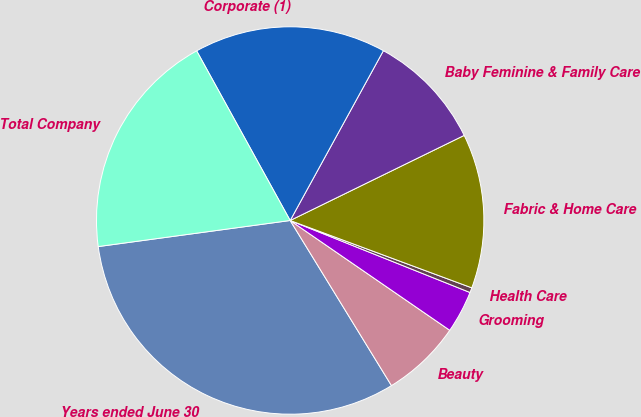Convert chart to OTSL. <chart><loc_0><loc_0><loc_500><loc_500><pie_chart><fcel>Years ended June 30<fcel>Beauty<fcel>Grooming<fcel>Health Care<fcel>Fabric & Home Care<fcel>Baby Feminine & Family Care<fcel>Corporate (1)<fcel>Total Company<nl><fcel>31.61%<fcel>6.65%<fcel>3.53%<fcel>0.41%<fcel>12.89%<fcel>9.77%<fcel>16.01%<fcel>19.13%<nl></chart> 